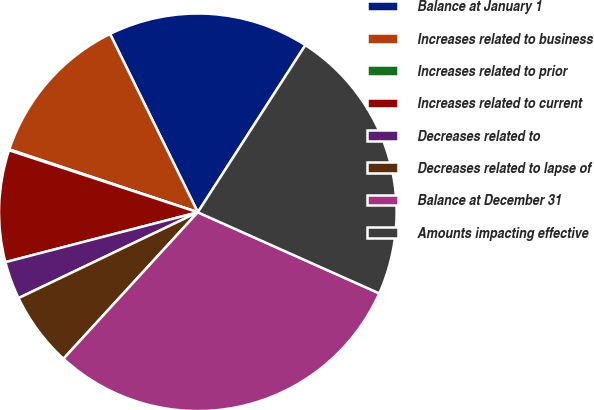<chart> <loc_0><loc_0><loc_500><loc_500><pie_chart><fcel>Balance at January 1<fcel>Increases related to business<fcel>Increases related to prior<fcel>Increases related to current<fcel>Decreases related to<fcel>Decreases related to lapse of<fcel>Balance at December 31<fcel>Amounts impacting effective<nl><fcel>16.38%<fcel>12.6%<fcel>0.07%<fcel>9.09%<fcel>3.07%<fcel>6.08%<fcel>30.13%<fcel>22.59%<nl></chart> 